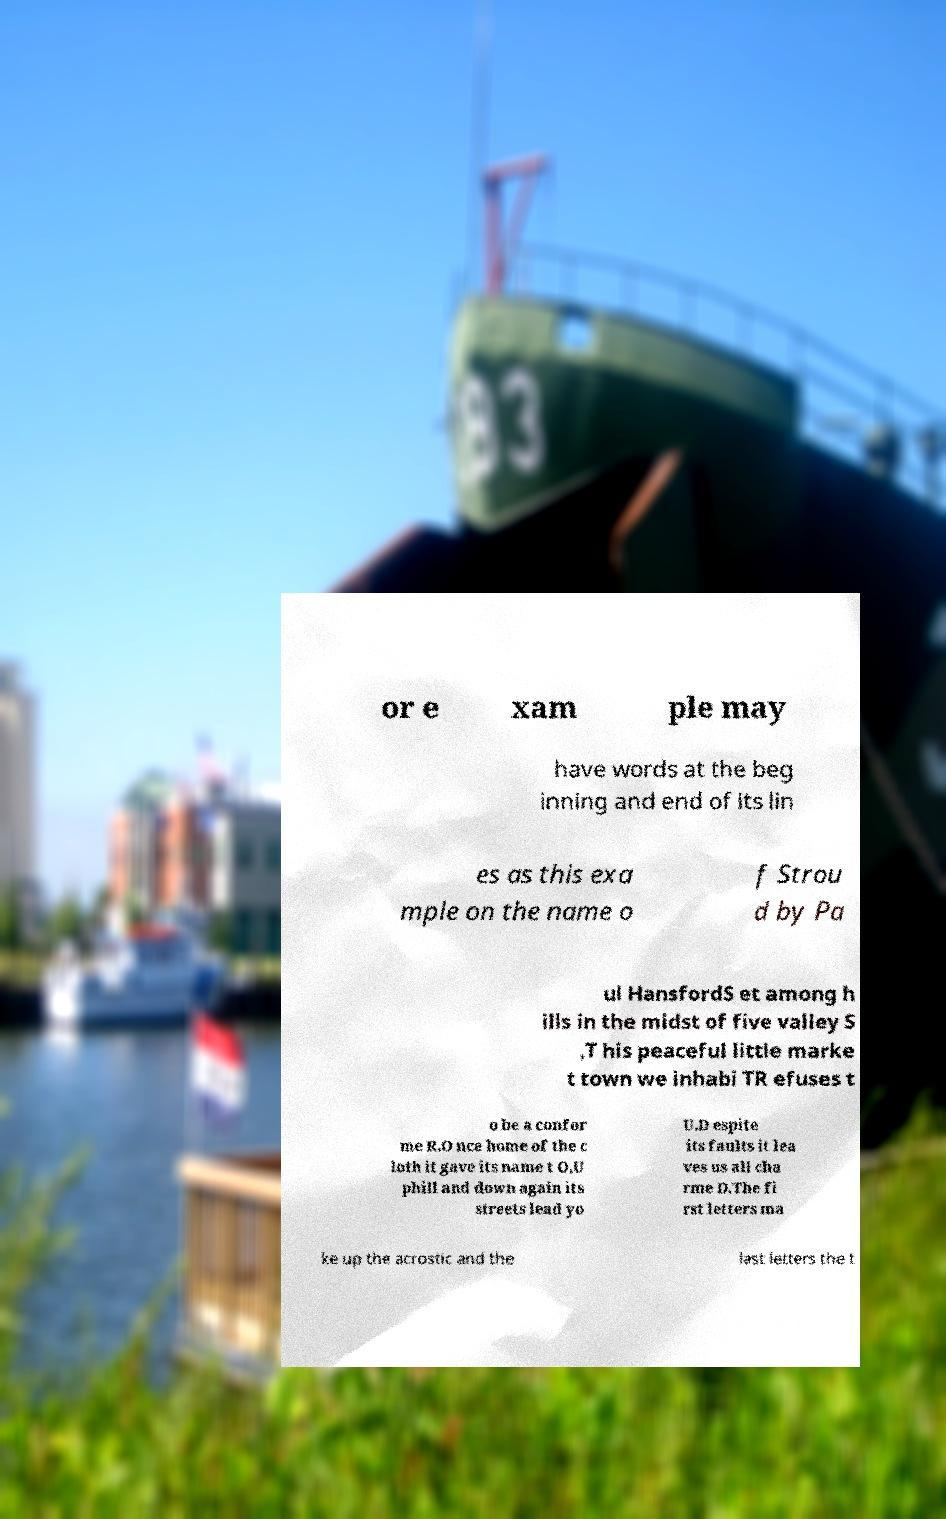Could you extract and type out the text from this image? or e xam ple may have words at the beg inning and end of its lin es as this exa mple on the name o f Strou d by Pa ul HansfordS et among h ills in the midst of five valley S ,T his peaceful little marke t town we inhabi TR efuses t o be a confor me R.O nce home of the c loth it gave its name t O,U phill and down again its streets lead yo U.D espite its faults it lea ves us all cha rme D.The fi rst letters ma ke up the acrostic and the last letters the t 